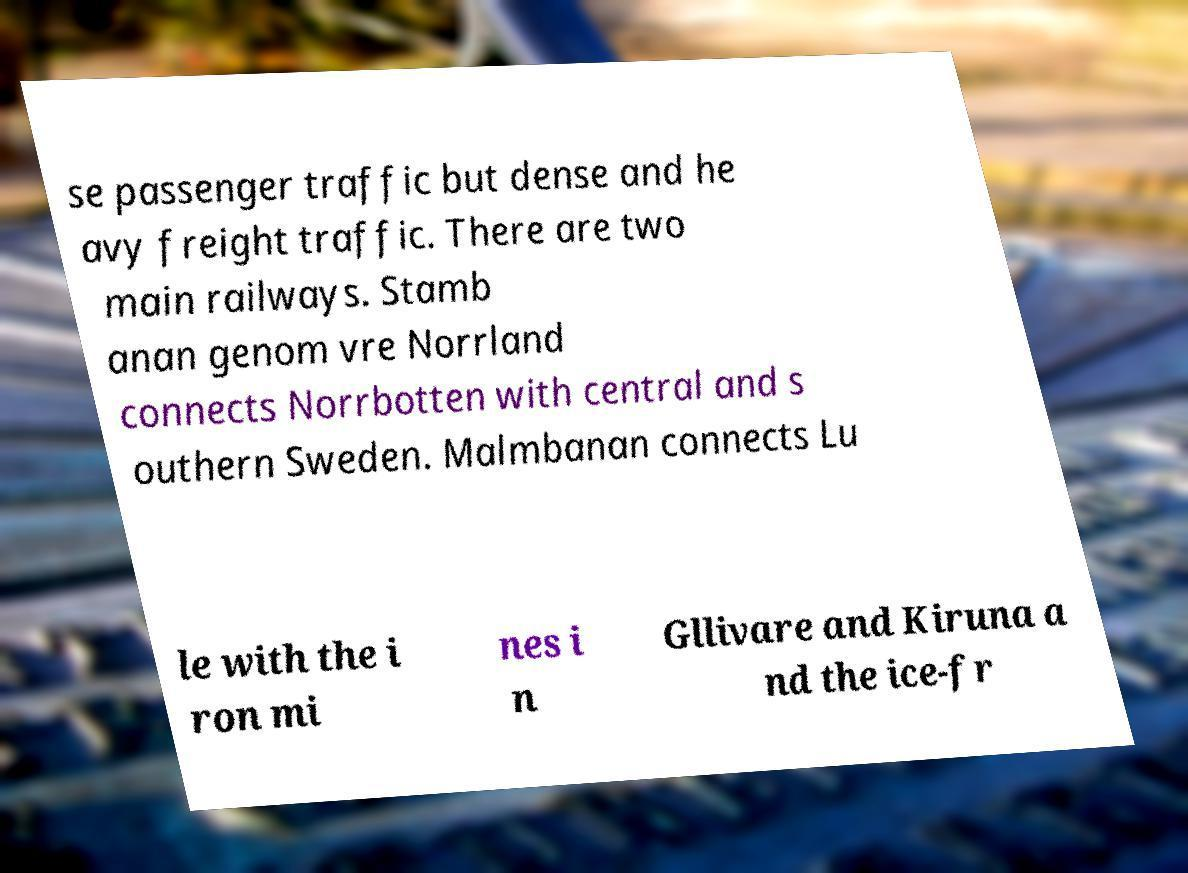I need the written content from this picture converted into text. Can you do that? se passenger traffic but dense and he avy freight traffic. There are two main railways. Stamb anan genom vre Norrland connects Norrbotten with central and s outhern Sweden. Malmbanan connects Lu le with the i ron mi nes i n Gllivare and Kiruna a nd the ice-fr 